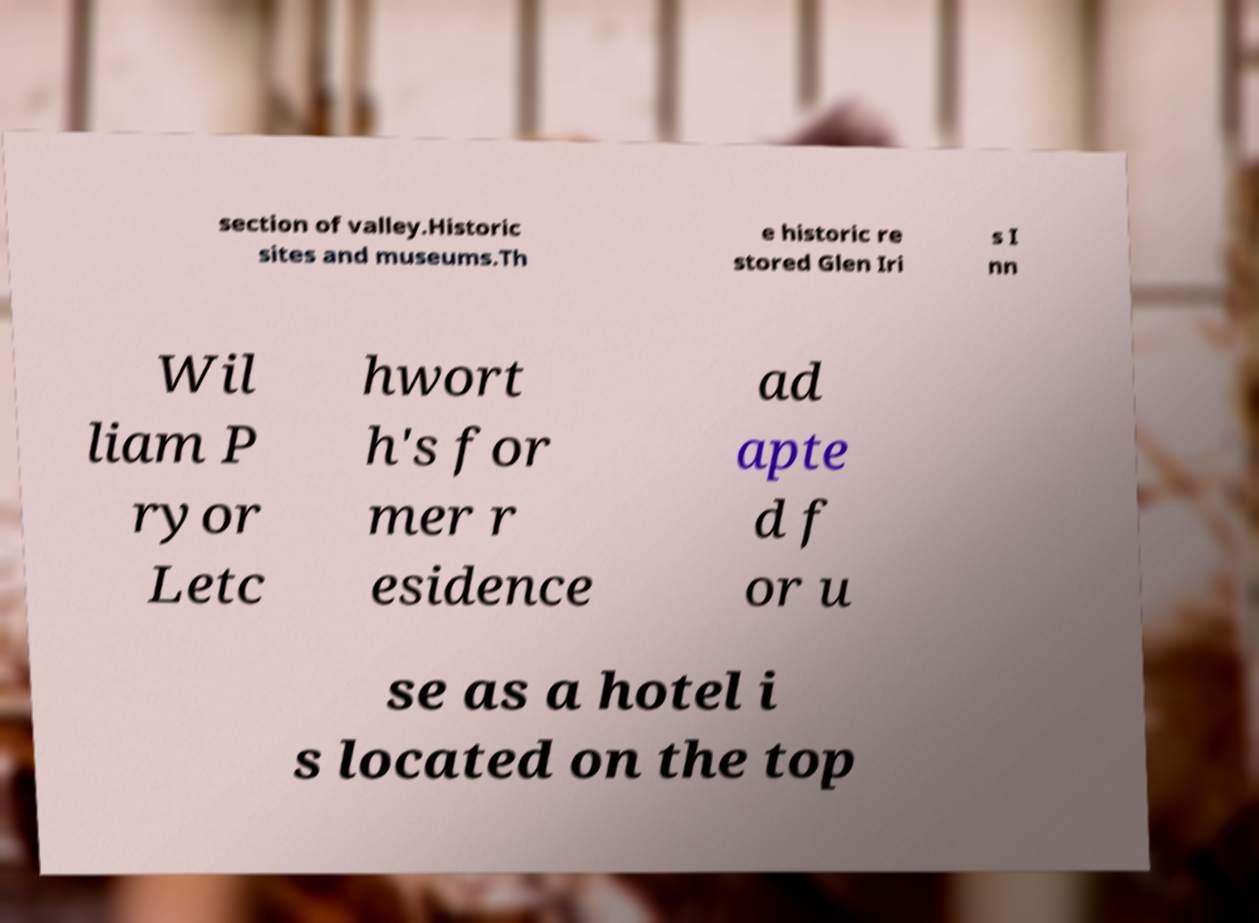I need the written content from this picture converted into text. Can you do that? section of valley.Historic sites and museums.Th e historic re stored Glen Iri s I nn Wil liam P ryor Letc hwort h's for mer r esidence ad apte d f or u se as a hotel i s located on the top 